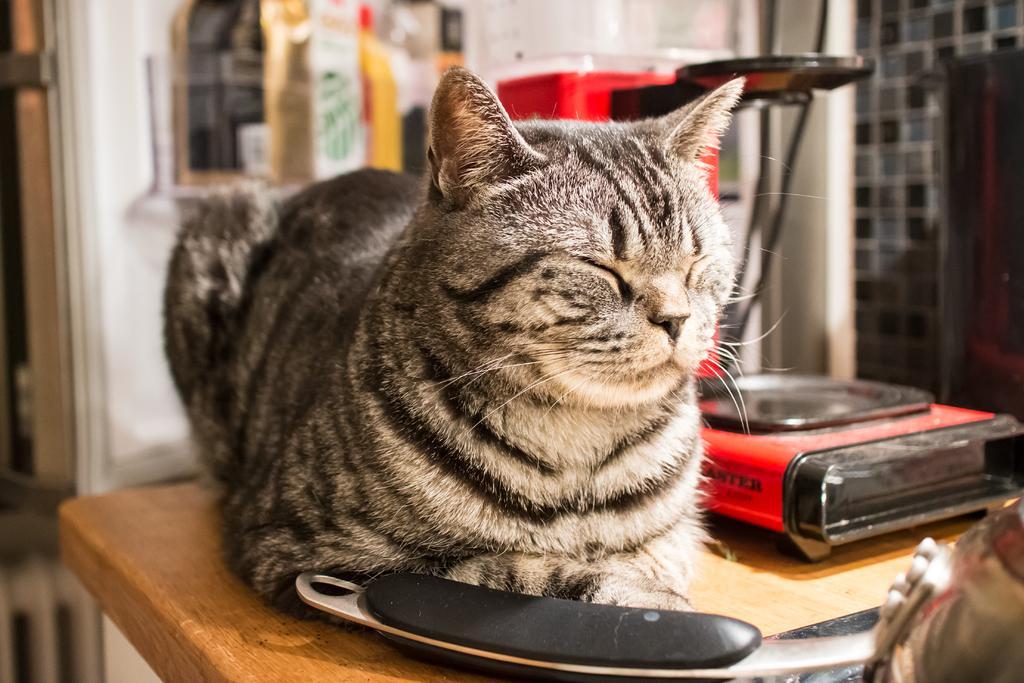Please provide a concise description of this image. In this image we can see a cat, a box and an object on the wooden surface, behind the cat we can see the wall, tiles, and some other objects, the background is blurred. 